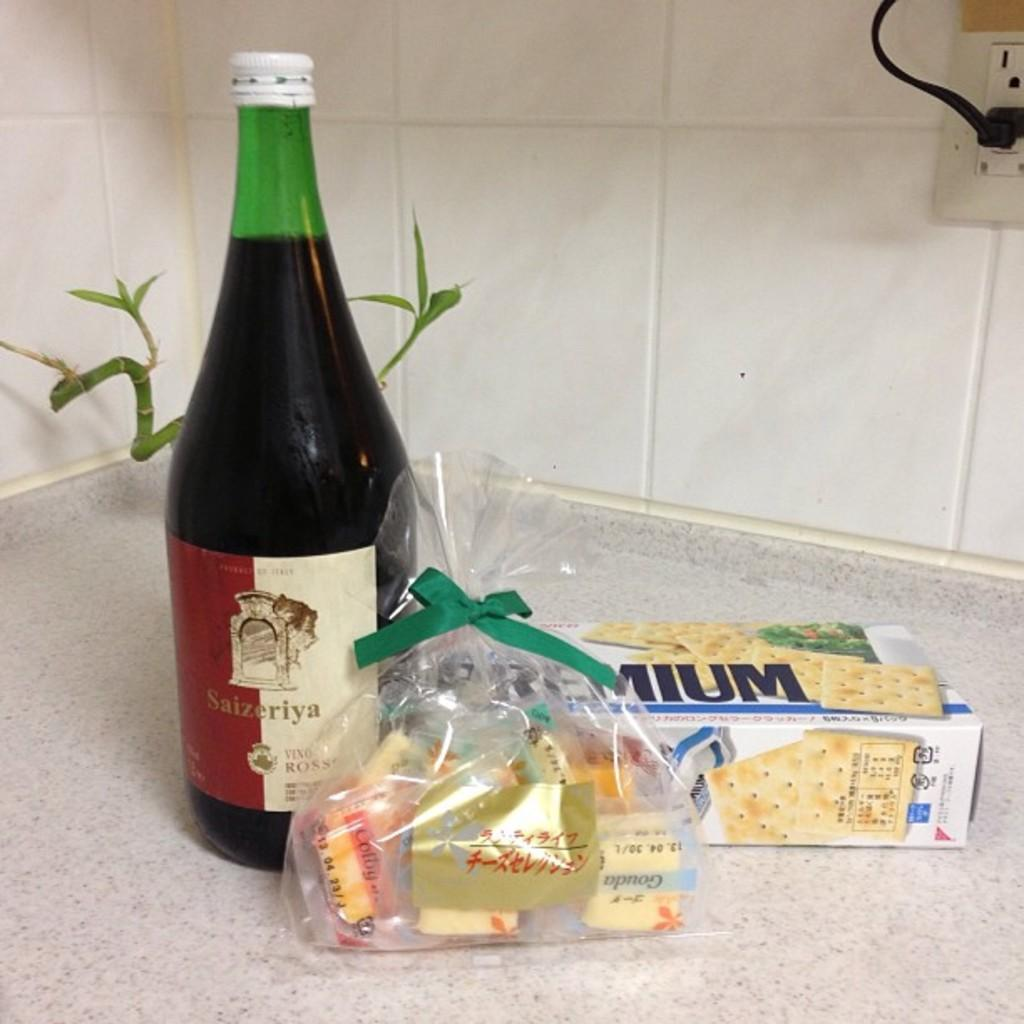What type of beverage container is present in the image? There is a wine bottle in the image. What is covering the wine bottle? There is a cover in the image. What type of edible items can be seen in the image? There are food items in the image. What is packaged in the image? There is a biscuit packet in the image. How does the collar fit on the wine bottle in the image? There is no collar present in the image; it only features a wine bottle, a cover, food items, and a biscuit packet. 